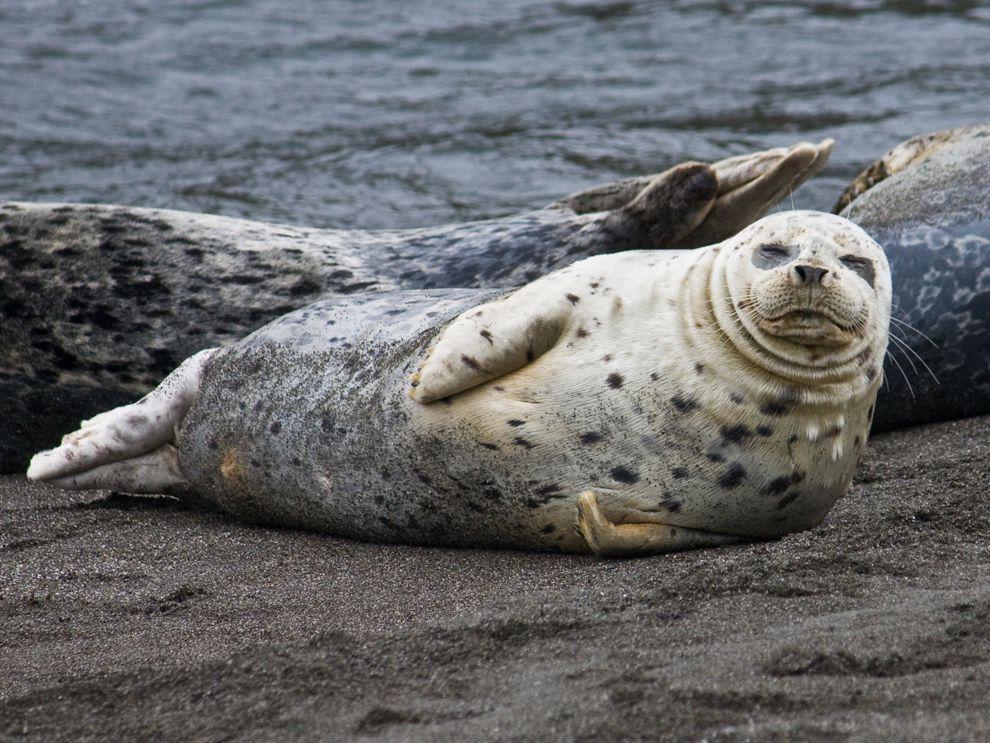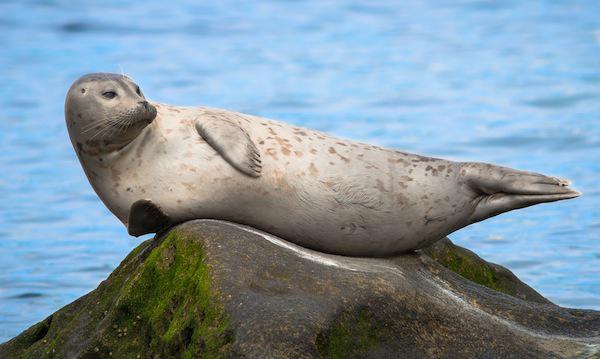The first image is the image on the left, the second image is the image on the right. For the images displayed, is the sentence "One image shows a seal lying on its side on a flat, unelevated surface with its head raised and turned to the camera." factually correct? Answer yes or no. Yes. The first image is the image on the left, the second image is the image on the right. For the images shown, is this caption "In the right image there is a single seal looking at the camera." true? Answer yes or no. No. 